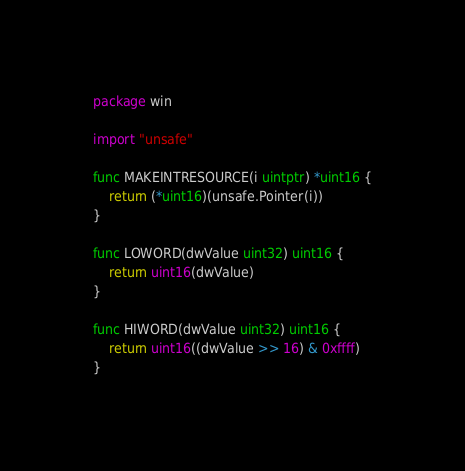Convert code to text. <code><loc_0><loc_0><loc_500><loc_500><_Go_>package win

import "unsafe"

func MAKEINTRESOURCE(i uintptr) *uint16 {
	return (*uint16)(unsafe.Pointer(i))
}

func LOWORD(dwValue uint32) uint16 {
	return uint16(dwValue)
}

func HIWORD(dwValue uint32) uint16 {
	return uint16((dwValue >> 16) & 0xffff)
}
</code> 